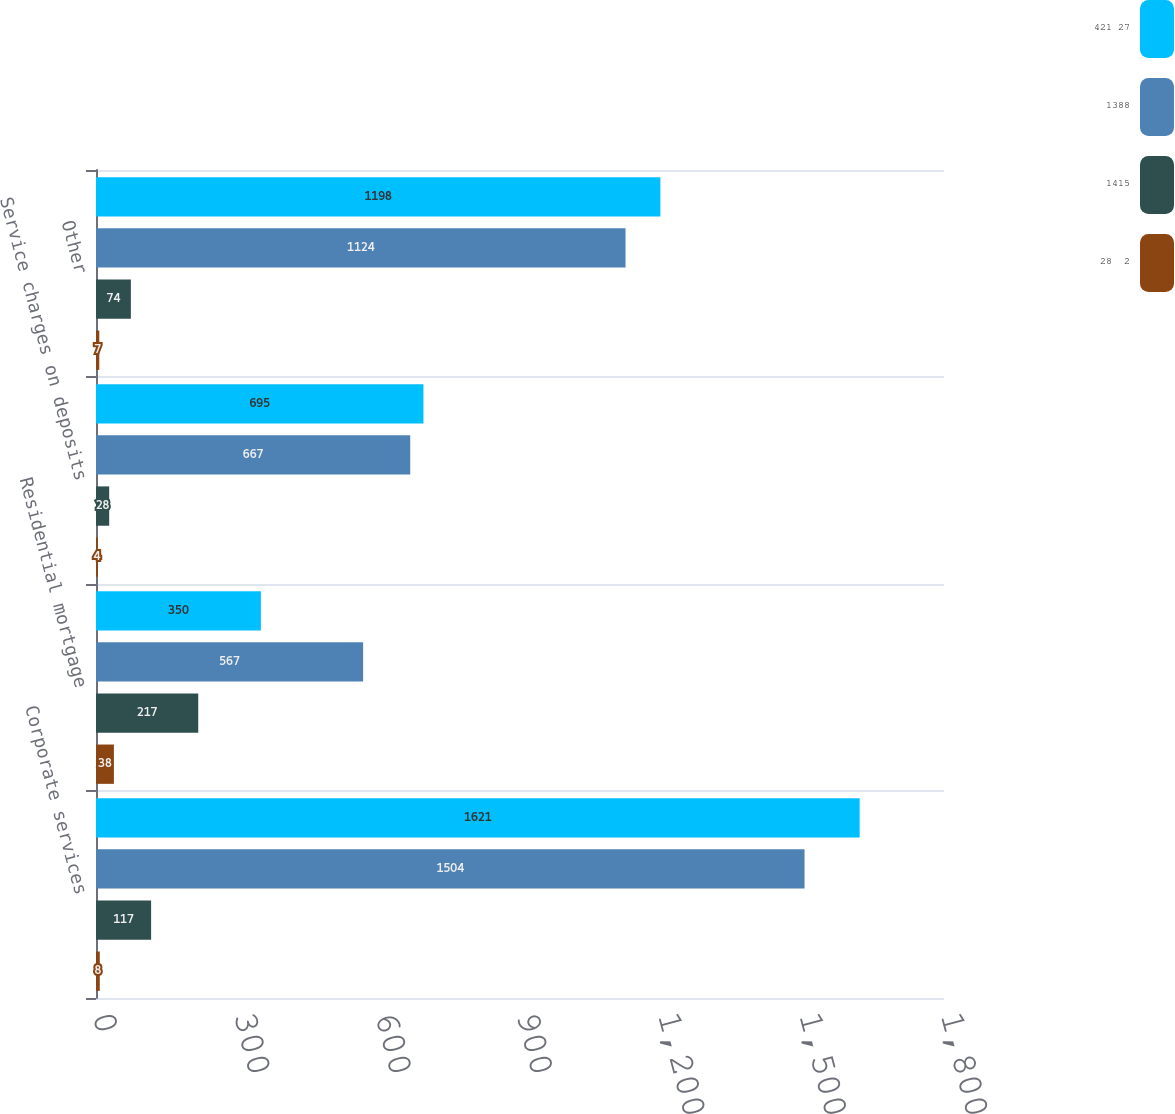Convert chart. <chart><loc_0><loc_0><loc_500><loc_500><stacked_bar_chart><ecel><fcel>Corporate services<fcel>Residential mortgage<fcel>Service charges on deposits<fcel>Other<nl><fcel>421 27<fcel>1621<fcel>350<fcel>695<fcel>1198<nl><fcel>1388<fcel>1504<fcel>567<fcel>667<fcel>1124<nl><fcel>1415<fcel>117<fcel>217<fcel>28<fcel>74<nl><fcel>28  2<fcel>8<fcel>38<fcel>4<fcel>7<nl></chart> 